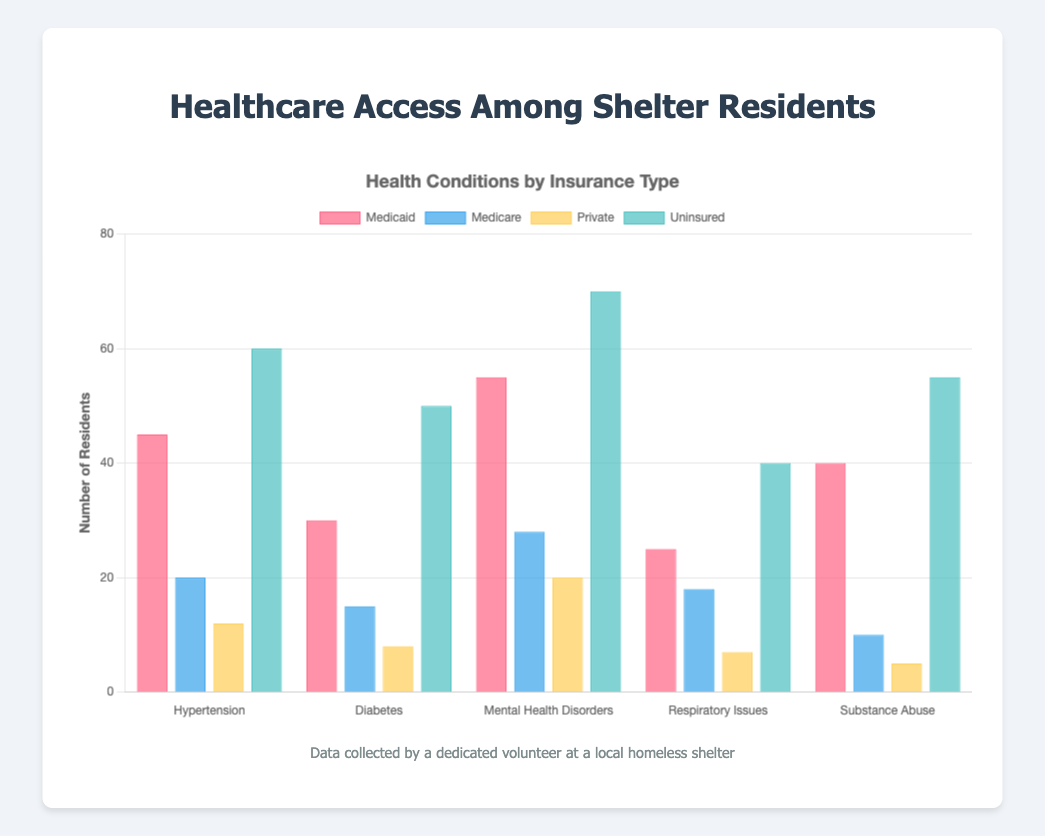Among Medicaid and Private insurance types, which one has more residents with Hypertension? Compare the number of residents with Hypertension for Medicaid (45) and Private (12). Medicaid has more residents with Hypertension.
Answer: Medicaid What is the total number of residents with Respiratory Issues across all insurance types? Sum the number of residents with Respiratory Issues across all insurance types: Medicaid (25) + Medicare (18) + Private (7) + Uninsured (40). So, 25 + 18 + 7 + 40 = 90.
Answer: 90 Which health condition has the most residents under the Uninsured category? Compare the number of residents for all health conditions under Uninsured: Hypertension (60), Diabetes (50), Mental Health Disorders (70), Respiratory Issues (40), and Substance Abuse (55). Mental Health Disorders is the highest with 70 residents.
Answer: Mental Health Disorders Among Medicare and Uninsured, which has fewer residents with Substance Abuse issues? Compare the number of residents with Substance Abuse under Medicare (10) and Uninsured (55). Medicare has fewer residents with Substance Abuse.
Answer: Medicare What is the average number of residents with health conditions for Medicaid? Calculate the average by summing the number of residents with health conditions under Medicaid: Hypertension (45) + Diabetes (30) + Mental Health Disorders (55) + Respiratory Issues (25) + Substance Abuse (40). The total is 45 + 30 + 55 + 25 + 40 = 195. There are 5 conditions, so 195 / 5 = 39.
Answer: 39 Does the number of residents with Diabetes increase or decrease as insurance coverage becomes less comprehensive (Medicaid to Medicare to Private to Uninsured)? Compare the number of residents with Diabetes across the insurance types in the order: Medicaid (30), Medicare (15), Private (8), Uninsured (50). The number decreases initially from Medicaid to Private but then increases significantly for Uninsured.
Answer: Increases What is the difference in the number of residents with Hypertension between the highest and lowest insurance types? Identify the highest (Uninsured = 60) and lowest (Private = 12) insurance types for residents with Hypertension. The difference is 60 - 12 = 48.
Answer: 48 Which insurance type has the fewest total residents considering all health conditions? Sum the number of residents across all health conditions for each insurance type and compare. Medicaid: 45 + 30 + 55 + 25 + 40 = 195, Medicare: 20 + 15 + 28 + 18 + 10 = 91, Private: 12 + 8 + 20 + 7 + 5 = 52, Uninsured: 60 + 50 + 70 + 40 + 55 = 275. Private has the fewest with 52 residents.
Answer: Private 